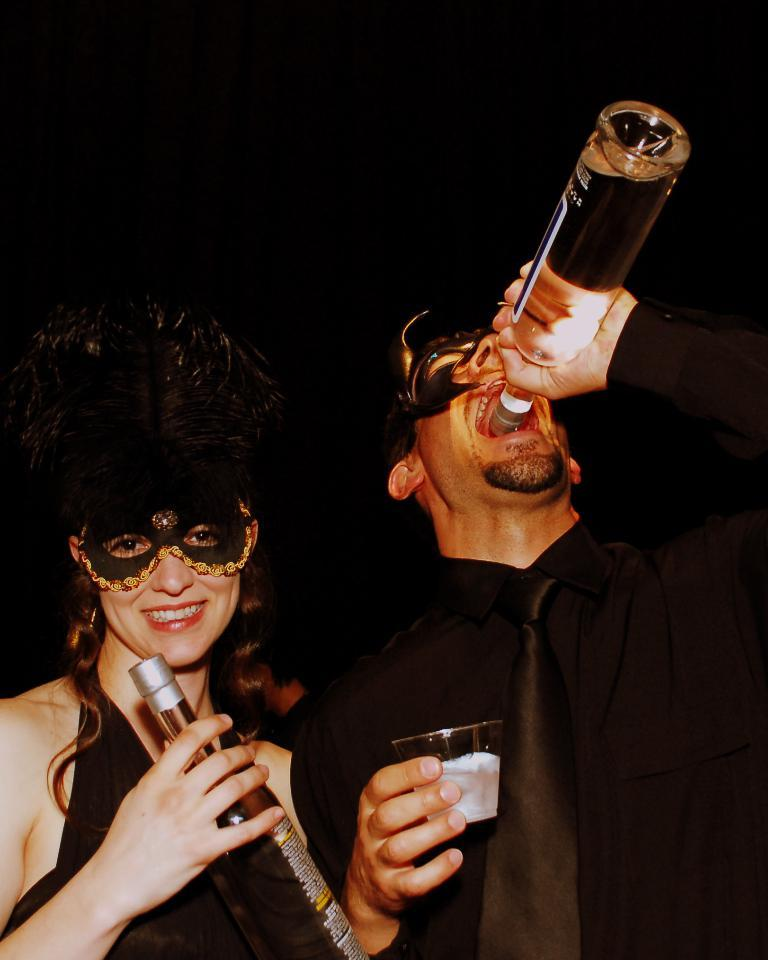What is the man in the image doing? The man is drinking from a bottle in the image. What else is the man holding in his hand? The man is holding a glass in his hand. Who else is present in the image? There is a woman in the image. What is the woman holding in her hands? The woman is holding a bottle in her hands. What is the woman's facial expression? The woman is smiling. What is the woman wearing on her head? The woman is wearing a head mask. What type of legal advice is the woman providing in the image? There is no indication in the image that the woman is providing legal advice or acting as a lawyer. 